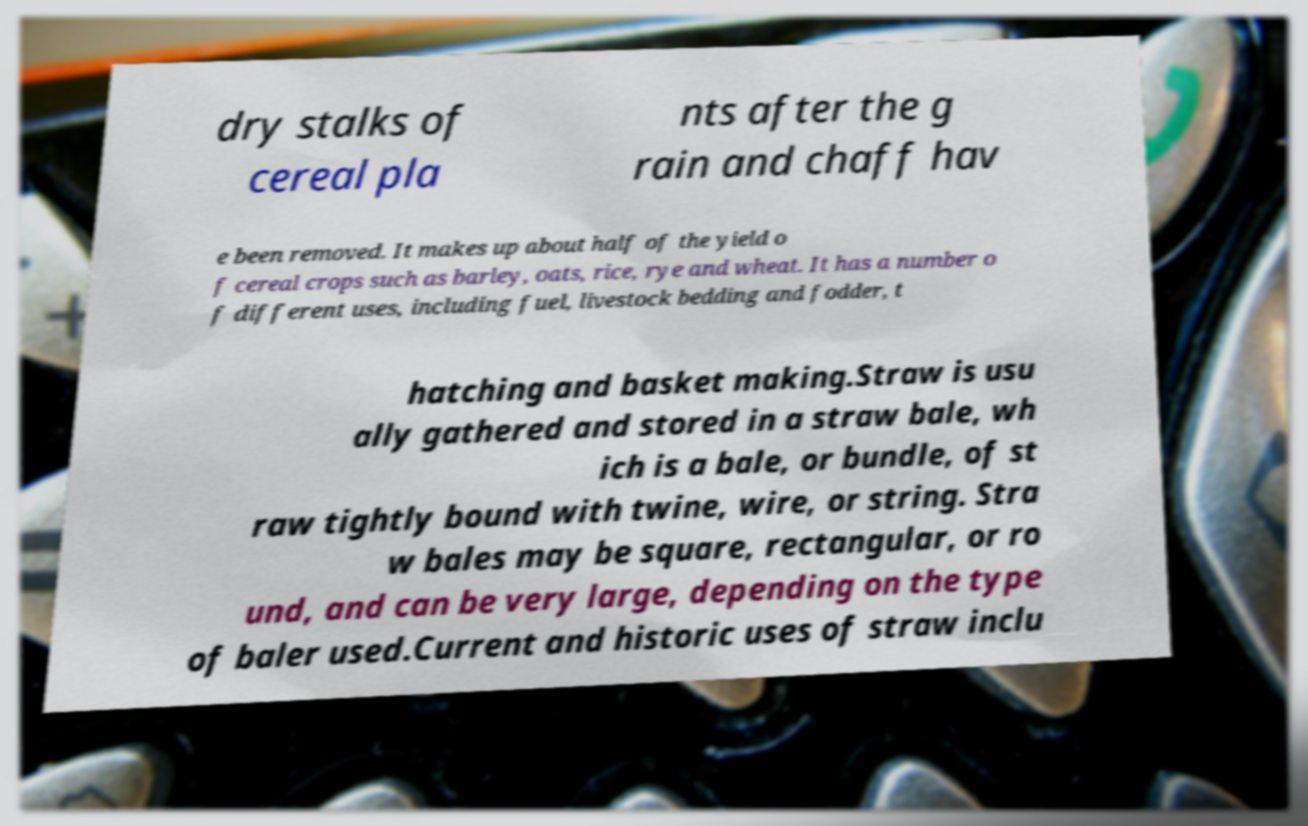I need the written content from this picture converted into text. Can you do that? dry stalks of cereal pla nts after the g rain and chaff hav e been removed. It makes up about half of the yield o f cereal crops such as barley, oats, rice, rye and wheat. It has a number o f different uses, including fuel, livestock bedding and fodder, t hatching and basket making.Straw is usu ally gathered and stored in a straw bale, wh ich is a bale, or bundle, of st raw tightly bound with twine, wire, or string. Stra w bales may be square, rectangular, or ro und, and can be very large, depending on the type of baler used.Current and historic uses of straw inclu 